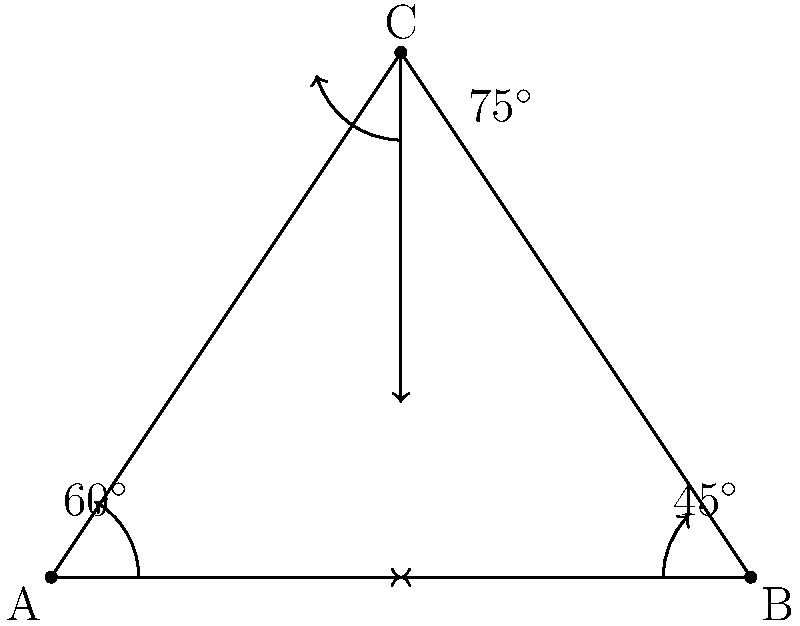Three wireless access points A, B, and C form a triangular network. The signal from A propagates at a $60^\circ$ angle, from B at a $45^\circ$ angle, and from C at a $75^\circ$ angle, all measured from the base of the triangle. What is the total coverage area of this network in square units if the base of the triangle is 4 units and its height is 3 units? To solve this problem, we'll follow these steps:

1) First, we need to calculate the area of the entire triangle ABC:
   Area of triangle = $\frac{1}{2} \times base \times height$
   $$ Area_{ABC} = \frac{1}{2} \times 4 \times 3 = 6 \text{ square units} $$

2) Now, we need to calculate the areas of the sectors covered by each access point:

   For A: $60^\circ$ is $\frac{1}{6}$ of a full circle (360°)
   $$ Area_A = \frac{1}{6} \times \pi r^2 $$

   For B: $45^\circ$ is $\frac{1}{8}$ of a full circle
   $$ Area_B = \frac{1}{8} \times \pi r^2 $$

   For C: $75^\circ$ is $\frac{5}{24}$ of a full circle
   $$ Area_C = \frac{5}{24} \times \pi r^2 $$

3) The radius for each sector is the same as the height of the triangle, 3 units.

4) Calculating the areas:
   $$ Area_A = \frac{1}{6} \times \pi \times 3^2 = \frac{3\pi}{2} $$
   $$ Area_B = \frac{1}{8} \times \pi \times 3^2 = \frac{9\pi}{8} $$
   $$ Area_C = \frac{5}{24} \times \pi \times 3^2 = \frac{15\pi}{8} $$

5) Total sector area:
   $$ Total_{sectors} = \frac{3\pi}{2} + \frac{9\pi}{8} + \frac{15\pi}{8} = \frac{39\pi}{8} $$

6) The coverage area is the union of the triangle and the sectors:
   $$ Coverage_{area} = Area_{ABC} + Total_{sectors} = 6 + \frac{39\pi}{8} $$

Therefore, the total coverage area is $6 + \frac{39\pi}{8}$ square units.
Answer: $6 + \frac{39\pi}{8}$ square units 